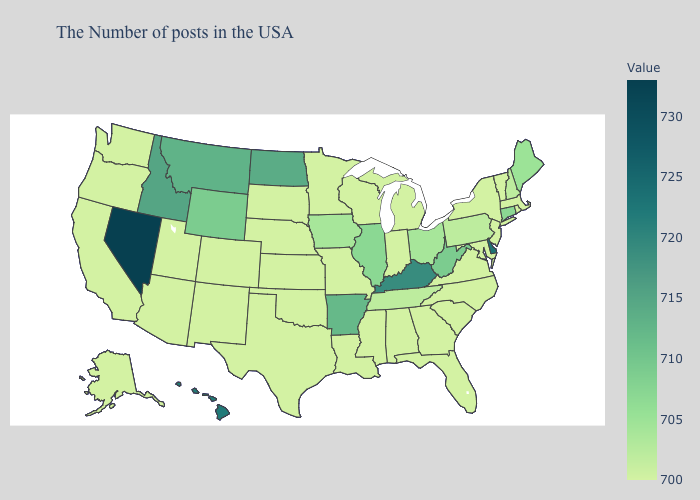Does Montana have the highest value in the West?
Be succinct. No. Does Texas have a lower value than Montana?
Be succinct. Yes. Which states have the lowest value in the USA?
Give a very brief answer. Massachusetts, Rhode Island, Vermont, New York, New Jersey, Maryland, Virginia, North Carolina, South Carolina, Florida, Georgia, Michigan, Indiana, Alabama, Wisconsin, Mississippi, Louisiana, Missouri, Minnesota, Kansas, Nebraska, Oklahoma, Texas, South Dakota, Colorado, New Mexico, Utah, Arizona, California, Washington, Oregon, Alaska. Which states have the lowest value in the West?
Write a very short answer. Colorado, New Mexico, Utah, Arizona, California, Washington, Oregon, Alaska. Is the legend a continuous bar?
Quick response, please. Yes. Among the states that border Illinois , which have the highest value?
Write a very short answer. Kentucky. Which states hav the highest value in the West?
Quick response, please. Nevada. Does Connecticut have the lowest value in the USA?
Write a very short answer. No. 